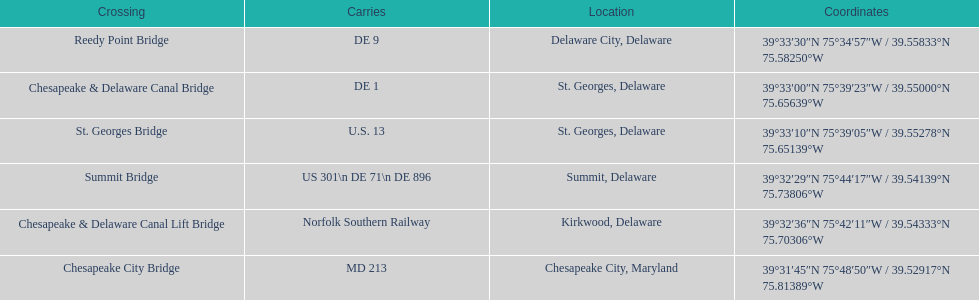Which bridge is in delaware and carries de 9? Reedy Point Bridge. 